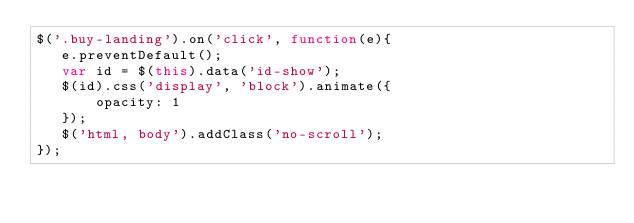<code> <loc_0><loc_0><loc_500><loc_500><_JavaScript_>$('.buy-landing').on('click', function(e){
   e.preventDefault();
   var id = $(this).data('id-show');
   $(id).css('display', 'block').animate({
       opacity: 1
   });
   $('html, body').addClass('no-scroll');
});</code> 